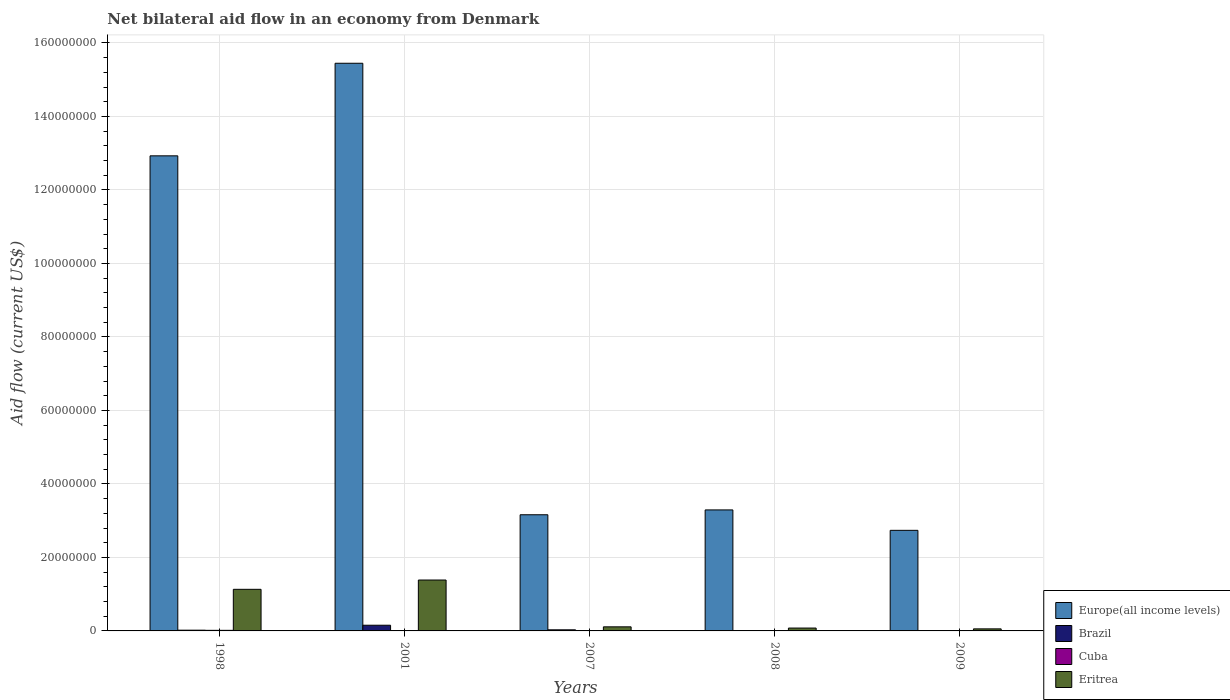Are the number of bars per tick equal to the number of legend labels?
Make the answer very short. No. Are the number of bars on each tick of the X-axis equal?
Provide a short and direct response. No. How many bars are there on the 5th tick from the right?
Ensure brevity in your answer.  4. What is the net bilateral aid flow in Eritrea in 2001?
Your answer should be compact. 1.38e+07. Across all years, what is the maximum net bilateral aid flow in Eritrea?
Your answer should be very brief. 1.38e+07. Across all years, what is the minimum net bilateral aid flow in Cuba?
Make the answer very short. 10000. What is the difference between the net bilateral aid flow in Eritrea in 1998 and that in 2009?
Ensure brevity in your answer.  1.08e+07. What is the difference between the net bilateral aid flow in Cuba in 2007 and the net bilateral aid flow in Europe(all income levels) in 1998?
Offer a terse response. -1.29e+08. In the year 1998, what is the difference between the net bilateral aid flow in Brazil and net bilateral aid flow in Europe(all income levels)?
Ensure brevity in your answer.  -1.29e+08. What is the ratio of the net bilateral aid flow in Europe(all income levels) in 2001 to that in 2007?
Give a very brief answer. 4.89. Is the net bilateral aid flow in Cuba in 1998 less than that in 2007?
Your answer should be compact. No. Is the difference between the net bilateral aid flow in Brazil in 2001 and 2007 greater than the difference between the net bilateral aid flow in Europe(all income levels) in 2001 and 2007?
Provide a short and direct response. No. What is the difference between the highest and the second highest net bilateral aid flow in Eritrea?
Keep it short and to the point. 2.53e+06. What is the difference between the highest and the lowest net bilateral aid flow in Brazil?
Provide a short and direct response. 1.55e+06. In how many years, is the net bilateral aid flow in Eritrea greater than the average net bilateral aid flow in Eritrea taken over all years?
Ensure brevity in your answer.  2. Is the sum of the net bilateral aid flow in Europe(all income levels) in 1998 and 2007 greater than the maximum net bilateral aid flow in Cuba across all years?
Offer a very short reply. Yes. Is it the case that in every year, the sum of the net bilateral aid flow in Brazil and net bilateral aid flow in Europe(all income levels) is greater than the sum of net bilateral aid flow in Cuba and net bilateral aid flow in Eritrea?
Offer a terse response. No. Is it the case that in every year, the sum of the net bilateral aid flow in Cuba and net bilateral aid flow in Europe(all income levels) is greater than the net bilateral aid flow in Brazil?
Offer a terse response. Yes. How many bars are there?
Your response must be concise. 19. How many years are there in the graph?
Your answer should be very brief. 5. What is the difference between two consecutive major ticks on the Y-axis?
Make the answer very short. 2.00e+07. Are the values on the major ticks of Y-axis written in scientific E-notation?
Your answer should be compact. No. Does the graph contain grids?
Your answer should be very brief. Yes. How many legend labels are there?
Provide a succinct answer. 4. How are the legend labels stacked?
Your answer should be compact. Vertical. What is the title of the graph?
Your answer should be very brief. Net bilateral aid flow in an economy from Denmark. What is the label or title of the X-axis?
Offer a very short reply. Years. What is the label or title of the Y-axis?
Offer a very short reply. Aid flow (current US$). What is the Aid flow (current US$) in Europe(all income levels) in 1998?
Provide a succinct answer. 1.29e+08. What is the Aid flow (current US$) of Brazil in 1998?
Give a very brief answer. 2.00e+05. What is the Aid flow (current US$) in Cuba in 1998?
Your answer should be compact. 1.60e+05. What is the Aid flow (current US$) of Eritrea in 1998?
Give a very brief answer. 1.13e+07. What is the Aid flow (current US$) of Europe(all income levels) in 2001?
Provide a succinct answer. 1.54e+08. What is the Aid flow (current US$) of Brazil in 2001?
Give a very brief answer. 1.55e+06. What is the Aid flow (current US$) in Cuba in 2001?
Your answer should be compact. 1.10e+05. What is the Aid flow (current US$) of Eritrea in 2001?
Ensure brevity in your answer.  1.38e+07. What is the Aid flow (current US$) of Europe(all income levels) in 2007?
Your answer should be compact. 3.16e+07. What is the Aid flow (current US$) in Eritrea in 2007?
Offer a terse response. 1.11e+06. What is the Aid flow (current US$) of Europe(all income levels) in 2008?
Give a very brief answer. 3.29e+07. What is the Aid flow (current US$) of Brazil in 2008?
Your answer should be very brief. 0. What is the Aid flow (current US$) in Eritrea in 2008?
Keep it short and to the point. 7.80e+05. What is the Aid flow (current US$) of Europe(all income levels) in 2009?
Offer a very short reply. 2.74e+07. What is the Aid flow (current US$) in Eritrea in 2009?
Provide a succinct answer. 5.60e+05. Across all years, what is the maximum Aid flow (current US$) in Europe(all income levels)?
Give a very brief answer. 1.54e+08. Across all years, what is the maximum Aid flow (current US$) of Brazil?
Your answer should be compact. 1.55e+06. Across all years, what is the maximum Aid flow (current US$) in Cuba?
Your answer should be very brief. 1.60e+05. Across all years, what is the maximum Aid flow (current US$) in Eritrea?
Your answer should be very brief. 1.38e+07. Across all years, what is the minimum Aid flow (current US$) of Europe(all income levels)?
Keep it short and to the point. 2.74e+07. Across all years, what is the minimum Aid flow (current US$) in Cuba?
Keep it short and to the point. 10000. Across all years, what is the minimum Aid flow (current US$) of Eritrea?
Your response must be concise. 5.60e+05. What is the total Aid flow (current US$) of Europe(all income levels) in the graph?
Your answer should be compact. 3.76e+08. What is the total Aid flow (current US$) of Brazil in the graph?
Provide a succinct answer. 2.06e+06. What is the total Aid flow (current US$) of Cuba in the graph?
Provide a succinct answer. 3.50e+05. What is the total Aid flow (current US$) in Eritrea in the graph?
Offer a terse response. 2.76e+07. What is the difference between the Aid flow (current US$) of Europe(all income levels) in 1998 and that in 2001?
Your answer should be very brief. -2.52e+07. What is the difference between the Aid flow (current US$) in Brazil in 1998 and that in 2001?
Ensure brevity in your answer.  -1.35e+06. What is the difference between the Aid flow (current US$) of Eritrea in 1998 and that in 2001?
Your answer should be compact. -2.53e+06. What is the difference between the Aid flow (current US$) in Europe(all income levels) in 1998 and that in 2007?
Keep it short and to the point. 9.77e+07. What is the difference between the Aid flow (current US$) of Eritrea in 1998 and that in 2007?
Your response must be concise. 1.02e+07. What is the difference between the Aid flow (current US$) in Europe(all income levels) in 1998 and that in 2008?
Offer a very short reply. 9.64e+07. What is the difference between the Aid flow (current US$) of Cuba in 1998 and that in 2008?
Your answer should be compact. 1.10e+05. What is the difference between the Aid flow (current US$) in Eritrea in 1998 and that in 2008?
Provide a short and direct response. 1.05e+07. What is the difference between the Aid flow (current US$) of Europe(all income levels) in 1998 and that in 2009?
Make the answer very short. 1.02e+08. What is the difference between the Aid flow (current US$) in Brazil in 1998 and that in 2009?
Make the answer very short. 1.90e+05. What is the difference between the Aid flow (current US$) of Cuba in 1998 and that in 2009?
Keep it short and to the point. 1.50e+05. What is the difference between the Aid flow (current US$) of Eritrea in 1998 and that in 2009?
Make the answer very short. 1.08e+07. What is the difference between the Aid flow (current US$) in Europe(all income levels) in 2001 and that in 2007?
Your answer should be compact. 1.23e+08. What is the difference between the Aid flow (current US$) in Brazil in 2001 and that in 2007?
Ensure brevity in your answer.  1.25e+06. What is the difference between the Aid flow (current US$) in Cuba in 2001 and that in 2007?
Your answer should be compact. 9.00e+04. What is the difference between the Aid flow (current US$) in Eritrea in 2001 and that in 2007?
Provide a short and direct response. 1.27e+07. What is the difference between the Aid flow (current US$) in Europe(all income levels) in 2001 and that in 2008?
Offer a very short reply. 1.22e+08. What is the difference between the Aid flow (current US$) in Cuba in 2001 and that in 2008?
Offer a terse response. 6.00e+04. What is the difference between the Aid flow (current US$) in Eritrea in 2001 and that in 2008?
Your response must be concise. 1.31e+07. What is the difference between the Aid flow (current US$) in Europe(all income levels) in 2001 and that in 2009?
Make the answer very short. 1.27e+08. What is the difference between the Aid flow (current US$) of Brazil in 2001 and that in 2009?
Ensure brevity in your answer.  1.54e+06. What is the difference between the Aid flow (current US$) of Cuba in 2001 and that in 2009?
Make the answer very short. 1.00e+05. What is the difference between the Aid flow (current US$) of Eritrea in 2001 and that in 2009?
Your response must be concise. 1.33e+07. What is the difference between the Aid flow (current US$) of Europe(all income levels) in 2007 and that in 2008?
Offer a very short reply. -1.32e+06. What is the difference between the Aid flow (current US$) of Eritrea in 2007 and that in 2008?
Your answer should be compact. 3.30e+05. What is the difference between the Aid flow (current US$) of Europe(all income levels) in 2007 and that in 2009?
Offer a very short reply. 4.24e+06. What is the difference between the Aid flow (current US$) in Brazil in 2007 and that in 2009?
Your answer should be compact. 2.90e+05. What is the difference between the Aid flow (current US$) in Cuba in 2007 and that in 2009?
Provide a short and direct response. 10000. What is the difference between the Aid flow (current US$) of Eritrea in 2007 and that in 2009?
Provide a short and direct response. 5.50e+05. What is the difference between the Aid flow (current US$) of Europe(all income levels) in 2008 and that in 2009?
Provide a succinct answer. 5.56e+06. What is the difference between the Aid flow (current US$) in Eritrea in 2008 and that in 2009?
Keep it short and to the point. 2.20e+05. What is the difference between the Aid flow (current US$) in Europe(all income levels) in 1998 and the Aid flow (current US$) in Brazil in 2001?
Provide a succinct answer. 1.28e+08. What is the difference between the Aid flow (current US$) of Europe(all income levels) in 1998 and the Aid flow (current US$) of Cuba in 2001?
Offer a very short reply. 1.29e+08. What is the difference between the Aid flow (current US$) in Europe(all income levels) in 1998 and the Aid flow (current US$) in Eritrea in 2001?
Ensure brevity in your answer.  1.15e+08. What is the difference between the Aid flow (current US$) of Brazil in 1998 and the Aid flow (current US$) of Cuba in 2001?
Offer a terse response. 9.00e+04. What is the difference between the Aid flow (current US$) of Brazil in 1998 and the Aid flow (current US$) of Eritrea in 2001?
Your answer should be compact. -1.36e+07. What is the difference between the Aid flow (current US$) in Cuba in 1998 and the Aid flow (current US$) in Eritrea in 2001?
Your response must be concise. -1.37e+07. What is the difference between the Aid flow (current US$) of Europe(all income levels) in 1998 and the Aid flow (current US$) of Brazil in 2007?
Offer a terse response. 1.29e+08. What is the difference between the Aid flow (current US$) in Europe(all income levels) in 1998 and the Aid flow (current US$) in Cuba in 2007?
Make the answer very short. 1.29e+08. What is the difference between the Aid flow (current US$) in Europe(all income levels) in 1998 and the Aid flow (current US$) in Eritrea in 2007?
Provide a succinct answer. 1.28e+08. What is the difference between the Aid flow (current US$) of Brazil in 1998 and the Aid flow (current US$) of Cuba in 2007?
Your response must be concise. 1.80e+05. What is the difference between the Aid flow (current US$) of Brazil in 1998 and the Aid flow (current US$) of Eritrea in 2007?
Provide a succinct answer. -9.10e+05. What is the difference between the Aid flow (current US$) of Cuba in 1998 and the Aid flow (current US$) of Eritrea in 2007?
Make the answer very short. -9.50e+05. What is the difference between the Aid flow (current US$) in Europe(all income levels) in 1998 and the Aid flow (current US$) in Cuba in 2008?
Provide a succinct answer. 1.29e+08. What is the difference between the Aid flow (current US$) in Europe(all income levels) in 1998 and the Aid flow (current US$) in Eritrea in 2008?
Your answer should be compact. 1.28e+08. What is the difference between the Aid flow (current US$) of Brazil in 1998 and the Aid flow (current US$) of Cuba in 2008?
Ensure brevity in your answer.  1.50e+05. What is the difference between the Aid flow (current US$) in Brazil in 1998 and the Aid flow (current US$) in Eritrea in 2008?
Provide a succinct answer. -5.80e+05. What is the difference between the Aid flow (current US$) in Cuba in 1998 and the Aid flow (current US$) in Eritrea in 2008?
Your response must be concise. -6.20e+05. What is the difference between the Aid flow (current US$) in Europe(all income levels) in 1998 and the Aid flow (current US$) in Brazil in 2009?
Provide a succinct answer. 1.29e+08. What is the difference between the Aid flow (current US$) in Europe(all income levels) in 1998 and the Aid flow (current US$) in Cuba in 2009?
Keep it short and to the point. 1.29e+08. What is the difference between the Aid flow (current US$) in Europe(all income levels) in 1998 and the Aid flow (current US$) in Eritrea in 2009?
Provide a short and direct response. 1.29e+08. What is the difference between the Aid flow (current US$) in Brazil in 1998 and the Aid flow (current US$) in Cuba in 2009?
Provide a succinct answer. 1.90e+05. What is the difference between the Aid flow (current US$) of Brazil in 1998 and the Aid flow (current US$) of Eritrea in 2009?
Provide a short and direct response. -3.60e+05. What is the difference between the Aid flow (current US$) of Cuba in 1998 and the Aid flow (current US$) of Eritrea in 2009?
Keep it short and to the point. -4.00e+05. What is the difference between the Aid flow (current US$) of Europe(all income levels) in 2001 and the Aid flow (current US$) of Brazil in 2007?
Your response must be concise. 1.54e+08. What is the difference between the Aid flow (current US$) of Europe(all income levels) in 2001 and the Aid flow (current US$) of Cuba in 2007?
Offer a terse response. 1.54e+08. What is the difference between the Aid flow (current US$) of Europe(all income levels) in 2001 and the Aid flow (current US$) of Eritrea in 2007?
Offer a very short reply. 1.53e+08. What is the difference between the Aid flow (current US$) of Brazil in 2001 and the Aid flow (current US$) of Cuba in 2007?
Your answer should be compact. 1.53e+06. What is the difference between the Aid flow (current US$) in Brazil in 2001 and the Aid flow (current US$) in Eritrea in 2007?
Ensure brevity in your answer.  4.40e+05. What is the difference between the Aid flow (current US$) of Cuba in 2001 and the Aid flow (current US$) of Eritrea in 2007?
Give a very brief answer. -1.00e+06. What is the difference between the Aid flow (current US$) in Europe(all income levels) in 2001 and the Aid flow (current US$) in Cuba in 2008?
Keep it short and to the point. 1.54e+08. What is the difference between the Aid flow (current US$) in Europe(all income levels) in 2001 and the Aid flow (current US$) in Eritrea in 2008?
Offer a terse response. 1.54e+08. What is the difference between the Aid flow (current US$) of Brazil in 2001 and the Aid flow (current US$) of Cuba in 2008?
Make the answer very short. 1.50e+06. What is the difference between the Aid flow (current US$) in Brazil in 2001 and the Aid flow (current US$) in Eritrea in 2008?
Your answer should be compact. 7.70e+05. What is the difference between the Aid flow (current US$) in Cuba in 2001 and the Aid flow (current US$) in Eritrea in 2008?
Make the answer very short. -6.70e+05. What is the difference between the Aid flow (current US$) in Europe(all income levels) in 2001 and the Aid flow (current US$) in Brazil in 2009?
Provide a succinct answer. 1.54e+08. What is the difference between the Aid flow (current US$) of Europe(all income levels) in 2001 and the Aid flow (current US$) of Cuba in 2009?
Give a very brief answer. 1.54e+08. What is the difference between the Aid flow (current US$) in Europe(all income levels) in 2001 and the Aid flow (current US$) in Eritrea in 2009?
Give a very brief answer. 1.54e+08. What is the difference between the Aid flow (current US$) in Brazil in 2001 and the Aid flow (current US$) in Cuba in 2009?
Ensure brevity in your answer.  1.54e+06. What is the difference between the Aid flow (current US$) in Brazil in 2001 and the Aid flow (current US$) in Eritrea in 2009?
Your answer should be compact. 9.90e+05. What is the difference between the Aid flow (current US$) in Cuba in 2001 and the Aid flow (current US$) in Eritrea in 2009?
Ensure brevity in your answer.  -4.50e+05. What is the difference between the Aid flow (current US$) of Europe(all income levels) in 2007 and the Aid flow (current US$) of Cuba in 2008?
Keep it short and to the point. 3.16e+07. What is the difference between the Aid flow (current US$) in Europe(all income levels) in 2007 and the Aid flow (current US$) in Eritrea in 2008?
Provide a short and direct response. 3.08e+07. What is the difference between the Aid flow (current US$) of Brazil in 2007 and the Aid flow (current US$) of Cuba in 2008?
Your response must be concise. 2.50e+05. What is the difference between the Aid flow (current US$) of Brazil in 2007 and the Aid flow (current US$) of Eritrea in 2008?
Offer a very short reply. -4.80e+05. What is the difference between the Aid flow (current US$) of Cuba in 2007 and the Aid flow (current US$) of Eritrea in 2008?
Give a very brief answer. -7.60e+05. What is the difference between the Aid flow (current US$) of Europe(all income levels) in 2007 and the Aid flow (current US$) of Brazil in 2009?
Offer a terse response. 3.16e+07. What is the difference between the Aid flow (current US$) in Europe(all income levels) in 2007 and the Aid flow (current US$) in Cuba in 2009?
Your answer should be very brief. 3.16e+07. What is the difference between the Aid flow (current US$) in Europe(all income levels) in 2007 and the Aid flow (current US$) in Eritrea in 2009?
Make the answer very short. 3.10e+07. What is the difference between the Aid flow (current US$) in Cuba in 2007 and the Aid flow (current US$) in Eritrea in 2009?
Your answer should be compact. -5.40e+05. What is the difference between the Aid flow (current US$) in Europe(all income levels) in 2008 and the Aid flow (current US$) in Brazil in 2009?
Your answer should be compact. 3.29e+07. What is the difference between the Aid flow (current US$) in Europe(all income levels) in 2008 and the Aid flow (current US$) in Cuba in 2009?
Your answer should be compact. 3.29e+07. What is the difference between the Aid flow (current US$) in Europe(all income levels) in 2008 and the Aid flow (current US$) in Eritrea in 2009?
Provide a succinct answer. 3.24e+07. What is the difference between the Aid flow (current US$) of Cuba in 2008 and the Aid flow (current US$) of Eritrea in 2009?
Provide a short and direct response. -5.10e+05. What is the average Aid flow (current US$) in Europe(all income levels) per year?
Your response must be concise. 7.51e+07. What is the average Aid flow (current US$) of Brazil per year?
Keep it short and to the point. 4.12e+05. What is the average Aid flow (current US$) in Cuba per year?
Keep it short and to the point. 7.00e+04. What is the average Aid flow (current US$) of Eritrea per year?
Offer a terse response. 5.52e+06. In the year 1998, what is the difference between the Aid flow (current US$) of Europe(all income levels) and Aid flow (current US$) of Brazil?
Offer a terse response. 1.29e+08. In the year 1998, what is the difference between the Aid flow (current US$) of Europe(all income levels) and Aid flow (current US$) of Cuba?
Offer a terse response. 1.29e+08. In the year 1998, what is the difference between the Aid flow (current US$) of Europe(all income levels) and Aid flow (current US$) of Eritrea?
Offer a very short reply. 1.18e+08. In the year 1998, what is the difference between the Aid flow (current US$) in Brazil and Aid flow (current US$) in Eritrea?
Your response must be concise. -1.11e+07. In the year 1998, what is the difference between the Aid flow (current US$) of Cuba and Aid flow (current US$) of Eritrea?
Your answer should be compact. -1.12e+07. In the year 2001, what is the difference between the Aid flow (current US$) in Europe(all income levels) and Aid flow (current US$) in Brazil?
Keep it short and to the point. 1.53e+08. In the year 2001, what is the difference between the Aid flow (current US$) in Europe(all income levels) and Aid flow (current US$) in Cuba?
Your response must be concise. 1.54e+08. In the year 2001, what is the difference between the Aid flow (current US$) in Europe(all income levels) and Aid flow (current US$) in Eritrea?
Give a very brief answer. 1.41e+08. In the year 2001, what is the difference between the Aid flow (current US$) of Brazil and Aid flow (current US$) of Cuba?
Provide a short and direct response. 1.44e+06. In the year 2001, what is the difference between the Aid flow (current US$) in Brazil and Aid flow (current US$) in Eritrea?
Offer a terse response. -1.23e+07. In the year 2001, what is the difference between the Aid flow (current US$) in Cuba and Aid flow (current US$) in Eritrea?
Keep it short and to the point. -1.37e+07. In the year 2007, what is the difference between the Aid flow (current US$) of Europe(all income levels) and Aid flow (current US$) of Brazil?
Your response must be concise. 3.13e+07. In the year 2007, what is the difference between the Aid flow (current US$) of Europe(all income levels) and Aid flow (current US$) of Cuba?
Your answer should be very brief. 3.16e+07. In the year 2007, what is the difference between the Aid flow (current US$) of Europe(all income levels) and Aid flow (current US$) of Eritrea?
Provide a succinct answer. 3.05e+07. In the year 2007, what is the difference between the Aid flow (current US$) in Brazil and Aid flow (current US$) in Eritrea?
Your answer should be very brief. -8.10e+05. In the year 2007, what is the difference between the Aid flow (current US$) of Cuba and Aid flow (current US$) of Eritrea?
Offer a very short reply. -1.09e+06. In the year 2008, what is the difference between the Aid flow (current US$) of Europe(all income levels) and Aid flow (current US$) of Cuba?
Give a very brief answer. 3.29e+07. In the year 2008, what is the difference between the Aid flow (current US$) in Europe(all income levels) and Aid flow (current US$) in Eritrea?
Ensure brevity in your answer.  3.22e+07. In the year 2008, what is the difference between the Aid flow (current US$) in Cuba and Aid flow (current US$) in Eritrea?
Your answer should be compact. -7.30e+05. In the year 2009, what is the difference between the Aid flow (current US$) in Europe(all income levels) and Aid flow (current US$) in Brazil?
Give a very brief answer. 2.74e+07. In the year 2009, what is the difference between the Aid flow (current US$) of Europe(all income levels) and Aid flow (current US$) of Cuba?
Keep it short and to the point. 2.74e+07. In the year 2009, what is the difference between the Aid flow (current US$) in Europe(all income levels) and Aid flow (current US$) in Eritrea?
Ensure brevity in your answer.  2.68e+07. In the year 2009, what is the difference between the Aid flow (current US$) of Brazil and Aid flow (current US$) of Cuba?
Provide a succinct answer. 0. In the year 2009, what is the difference between the Aid flow (current US$) in Brazil and Aid flow (current US$) in Eritrea?
Provide a short and direct response. -5.50e+05. In the year 2009, what is the difference between the Aid flow (current US$) of Cuba and Aid flow (current US$) of Eritrea?
Provide a succinct answer. -5.50e+05. What is the ratio of the Aid flow (current US$) in Europe(all income levels) in 1998 to that in 2001?
Keep it short and to the point. 0.84. What is the ratio of the Aid flow (current US$) of Brazil in 1998 to that in 2001?
Make the answer very short. 0.13. What is the ratio of the Aid flow (current US$) in Cuba in 1998 to that in 2001?
Ensure brevity in your answer.  1.45. What is the ratio of the Aid flow (current US$) in Eritrea in 1998 to that in 2001?
Provide a short and direct response. 0.82. What is the ratio of the Aid flow (current US$) in Europe(all income levels) in 1998 to that in 2007?
Provide a short and direct response. 4.09. What is the ratio of the Aid flow (current US$) of Brazil in 1998 to that in 2007?
Ensure brevity in your answer.  0.67. What is the ratio of the Aid flow (current US$) of Eritrea in 1998 to that in 2007?
Your answer should be very brief. 10.2. What is the ratio of the Aid flow (current US$) of Europe(all income levels) in 1998 to that in 2008?
Provide a short and direct response. 3.93. What is the ratio of the Aid flow (current US$) of Eritrea in 1998 to that in 2008?
Make the answer very short. 14.51. What is the ratio of the Aid flow (current US$) of Europe(all income levels) in 1998 to that in 2009?
Offer a very short reply. 4.72. What is the ratio of the Aid flow (current US$) of Brazil in 1998 to that in 2009?
Offer a terse response. 20. What is the ratio of the Aid flow (current US$) of Cuba in 1998 to that in 2009?
Your response must be concise. 16. What is the ratio of the Aid flow (current US$) of Eritrea in 1998 to that in 2009?
Your response must be concise. 20.21. What is the ratio of the Aid flow (current US$) of Europe(all income levels) in 2001 to that in 2007?
Provide a short and direct response. 4.89. What is the ratio of the Aid flow (current US$) in Brazil in 2001 to that in 2007?
Ensure brevity in your answer.  5.17. What is the ratio of the Aid flow (current US$) of Eritrea in 2001 to that in 2007?
Provide a succinct answer. 12.48. What is the ratio of the Aid flow (current US$) of Europe(all income levels) in 2001 to that in 2008?
Give a very brief answer. 4.69. What is the ratio of the Aid flow (current US$) in Cuba in 2001 to that in 2008?
Offer a very short reply. 2.2. What is the ratio of the Aid flow (current US$) of Eritrea in 2001 to that in 2008?
Your answer should be compact. 17.76. What is the ratio of the Aid flow (current US$) of Europe(all income levels) in 2001 to that in 2009?
Make the answer very short. 5.64. What is the ratio of the Aid flow (current US$) of Brazil in 2001 to that in 2009?
Your response must be concise. 155. What is the ratio of the Aid flow (current US$) of Eritrea in 2001 to that in 2009?
Provide a short and direct response. 24.73. What is the ratio of the Aid flow (current US$) in Europe(all income levels) in 2007 to that in 2008?
Offer a terse response. 0.96. What is the ratio of the Aid flow (current US$) of Eritrea in 2007 to that in 2008?
Your response must be concise. 1.42. What is the ratio of the Aid flow (current US$) of Europe(all income levels) in 2007 to that in 2009?
Your answer should be compact. 1.15. What is the ratio of the Aid flow (current US$) in Brazil in 2007 to that in 2009?
Ensure brevity in your answer.  30. What is the ratio of the Aid flow (current US$) of Cuba in 2007 to that in 2009?
Make the answer very short. 2. What is the ratio of the Aid flow (current US$) in Eritrea in 2007 to that in 2009?
Provide a succinct answer. 1.98. What is the ratio of the Aid flow (current US$) of Europe(all income levels) in 2008 to that in 2009?
Provide a succinct answer. 1.2. What is the ratio of the Aid flow (current US$) of Cuba in 2008 to that in 2009?
Ensure brevity in your answer.  5. What is the ratio of the Aid flow (current US$) in Eritrea in 2008 to that in 2009?
Keep it short and to the point. 1.39. What is the difference between the highest and the second highest Aid flow (current US$) in Europe(all income levels)?
Make the answer very short. 2.52e+07. What is the difference between the highest and the second highest Aid flow (current US$) of Brazil?
Make the answer very short. 1.25e+06. What is the difference between the highest and the second highest Aid flow (current US$) in Eritrea?
Make the answer very short. 2.53e+06. What is the difference between the highest and the lowest Aid flow (current US$) in Europe(all income levels)?
Your response must be concise. 1.27e+08. What is the difference between the highest and the lowest Aid flow (current US$) in Brazil?
Provide a succinct answer. 1.55e+06. What is the difference between the highest and the lowest Aid flow (current US$) in Cuba?
Your response must be concise. 1.50e+05. What is the difference between the highest and the lowest Aid flow (current US$) in Eritrea?
Your response must be concise. 1.33e+07. 